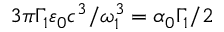Convert formula to latex. <formula><loc_0><loc_0><loc_500><loc_500>3 \pi \Gamma _ { 1 } \varepsilon _ { 0 } c ^ { 3 } / \omega _ { 1 } ^ { 3 } = \alpha _ { 0 } \Gamma _ { 1 } / 2</formula> 